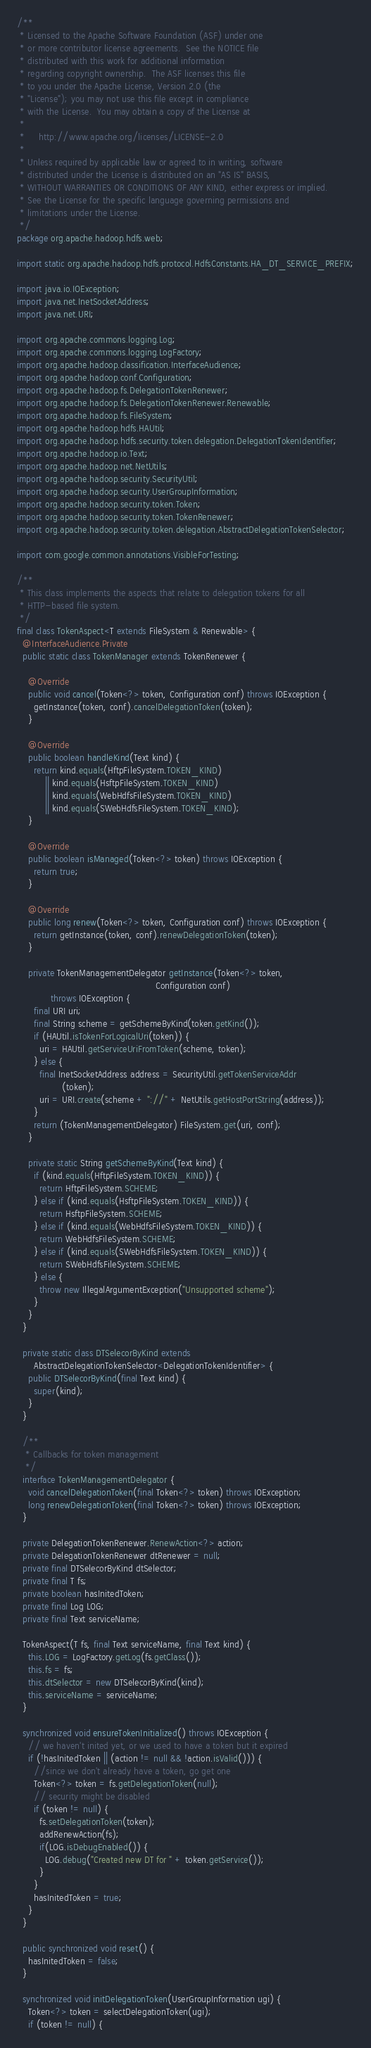<code> <loc_0><loc_0><loc_500><loc_500><_Java_>/**
 * Licensed to the Apache Software Foundation (ASF) under one
 * or more contributor license agreements.  See the NOTICE file
 * distributed with this work for additional information
 * regarding copyright ownership.  The ASF licenses this file
 * to you under the Apache License, Version 2.0 (the
 * "License"); you may not use this file except in compliance
 * with the License.  You may obtain a copy of the License at
 *
 *     http://www.apache.org/licenses/LICENSE-2.0
 *
 * Unless required by applicable law or agreed to in writing, software
 * distributed under the License is distributed on an "AS IS" BASIS,
 * WITHOUT WARRANTIES OR CONDITIONS OF ANY KIND, either express or implied.
 * See the License for the specific language governing permissions and
 * limitations under the License.
 */
package org.apache.hadoop.hdfs.web;

import static org.apache.hadoop.hdfs.protocol.HdfsConstants.HA_DT_SERVICE_PREFIX;

import java.io.IOException;
import java.net.InetSocketAddress;
import java.net.URI;

import org.apache.commons.logging.Log;
import org.apache.commons.logging.LogFactory;
import org.apache.hadoop.classification.InterfaceAudience;
import org.apache.hadoop.conf.Configuration;
import org.apache.hadoop.fs.DelegationTokenRenewer;
import org.apache.hadoop.fs.DelegationTokenRenewer.Renewable;
import org.apache.hadoop.fs.FileSystem;
import org.apache.hadoop.hdfs.HAUtil;
import org.apache.hadoop.hdfs.security.token.delegation.DelegationTokenIdentifier;
import org.apache.hadoop.io.Text;
import org.apache.hadoop.net.NetUtils;
import org.apache.hadoop.security.SecurityUtil;
import org.apache.hadoop.security.UserGroupInformation;
import org.apache.hadoop.security.token.Token;
import org.apache.hadoop.security.token.TokenRenewer;
import org.apache.hadoop.security.token.delegation.AbstractDelegationTokenSelector;

import com.google.common.annotations.VisibleForTesting;

/**
 * This class implements the aspects that relate to delegation tokens for all
 * HTTP-based file system.
 */
final class TokenAspect<T extends FileSystem & Renewable> {
  @InterfaceAudience.Private
  public static class TokenManager extends TokenRenewer {

    @Override
    public void cancel(Token<?> token, Configuration conf) throws IOException {
      getInstance(token, conf).cancelDelegationToken(token);
    }

    @Override
    public boolean handleKind(Text kind) {
      return kind.equals(HftpFileSystem.TOKEN_KIND)
          || kind.equals(HsftpFileSystem.TOKEN_KIND)
          || kind.equals(WebHdfsFileSystem.TOKEN_KIND)
          || kind.equals(SWebHdfsFileSystem.TOKEN_KIND);
    }

    @Override
    public boolean isManaged(Token<?> token) throws IOException {
      return true;
    }

    @Override
    public long renew(Token<?> token, Configuration conf) throws IOException {
      return getInstance(token, conf).renewDelegationToken(token);
    }

    private TokenManagementDelegator getInstance(Token<?> token,
                                                 Configuration conf)
            throws IOException {
      final URI uri;
      final String scheme = getSchemeByKind(token.getKind());
      if (HAUtil.isTokenForLogicalUri(token)) {
        uri = HAUtil.getServiceUriFromToken(scheme, token);
      } else {
        final InetSocketAddress address = SecurityUtil.getTokenServiceAddr
                (token);
        uri = URI.create(scheme + "://" + NetUtils.getHostPortString(address));
      }
      return (TokenManagementDelegator) FileSystem.get(uri, conf);
    }

    private static String getSchemeByKind(Text kind) {
      if (kind.equals(HftpFileSystem.TOKEN_KIND)) {
        return HftpFileSystem.SCHEME;
      } else if (kind.equals(HsftpFileSystem.TOKEN_KIND)) {
        return HsftpFileSystem.SCHEME;
      } else if (kind.equals(WebHdfsFileSystem.TOKEN_KIND)) {
        return WebHdfsFileSystem.SCHEME;
      } else if (kind.equals(SWebHdfsFileSystem.TOKEN_KIND)) {
        return SWebHdfsFileSystem.SCHEME;
      } else {
        throw new IllegalArgumentException("Unsupported scheme");
      }
    }
  }

  private static class DTSelecorByKind extends
      AbstractDelegationTokenSelector<DelegationTokenIdentifier> {
    public DTSelecorByKind(final Text kind) {
      super(kind);
    }
  }

  /**
   * Callbacks for token management
   */
  interface TokenManagementDelegator {
    void cancelDelegationToken(final Token<?> token) throws IOException;
    long renewDelegationToken(final Token<?> token) throws IOException;
  }

  private DelegationTokenRenewer.RenewAction<?> action;
  private DelegationTokenRenewer dtRenewer = null;
  private final DTSelecorByKind dtSelector;
  private final T fs;
  private boolean hasInitedToken;
  private final Log LOG;
  private final Text serviceName;

  TokenAspect(T fs, final Text serviceName, final Text kind) {
    this.LOG = LogFactory.getLog(fs.getClass());
    this.fs = fs;
    this.dtSelector = new DTSelecorByKind(kind);
    this.serviceName = serviceName;
  }

  synchronized void ensureTokenInitialized() throws IOException {
    // we haven't inited yet, or we used to have a token but it expired
    if (!hasInitedToken || (action != null && !action.isValid())) {
      //since we don't already have a token, go get one
      Token<?> token = fs.getDelegationToken(null);
      // security might be disabled
      if (token != null) {
        fs.setDelegationToken(token);
        addRenewAction(fs);
        if(LOG.isDebugEnabled()) {
          LOG.debug("Created new DT for " + token.getService());
        }
      }
      hasInitedToken = true;
    }
  }

  public synchronized void reset() {
    hasInitedToken = false;
  }

  synchronized void initDelegationToken(UserGroupInformation ugi) {
    Token<?> token = selectDelegationToken(ugi);
    if (token != null) {</code> 